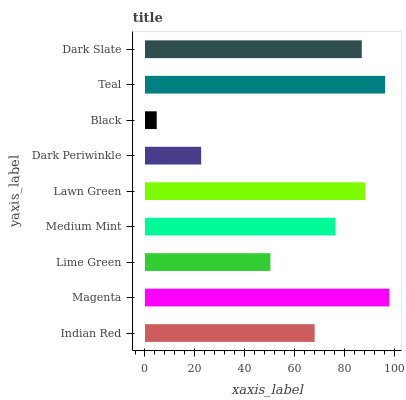Is Black the minimum?
Answer yes or no. Yes. Is Magenta the maximum?
Answer yes or no. Yes. Is Lime Green the minimum?
Answer yes or no. No. Is Lime Green the maximum?
Answer yes or no. No. Is Magenta greater than Lime Green?
Answer yes or no. Yes. Is Lime Green less than Magenta?
Answer yes or no. Yes. Is Lime Green greater than Magenta?
Answer yes or no. No. Is Magenta less than Lime Green?
Answer yes or no. No. Is Medium Mint the high median?
Answer yes or no. Yes. Is Medium Mint the low median?
Answer yes or no. Yes. Is Lawn Green the high median?
Answer yes or no. No. Is Dark Periwinkle the low median?
Answer yes or no. No. 